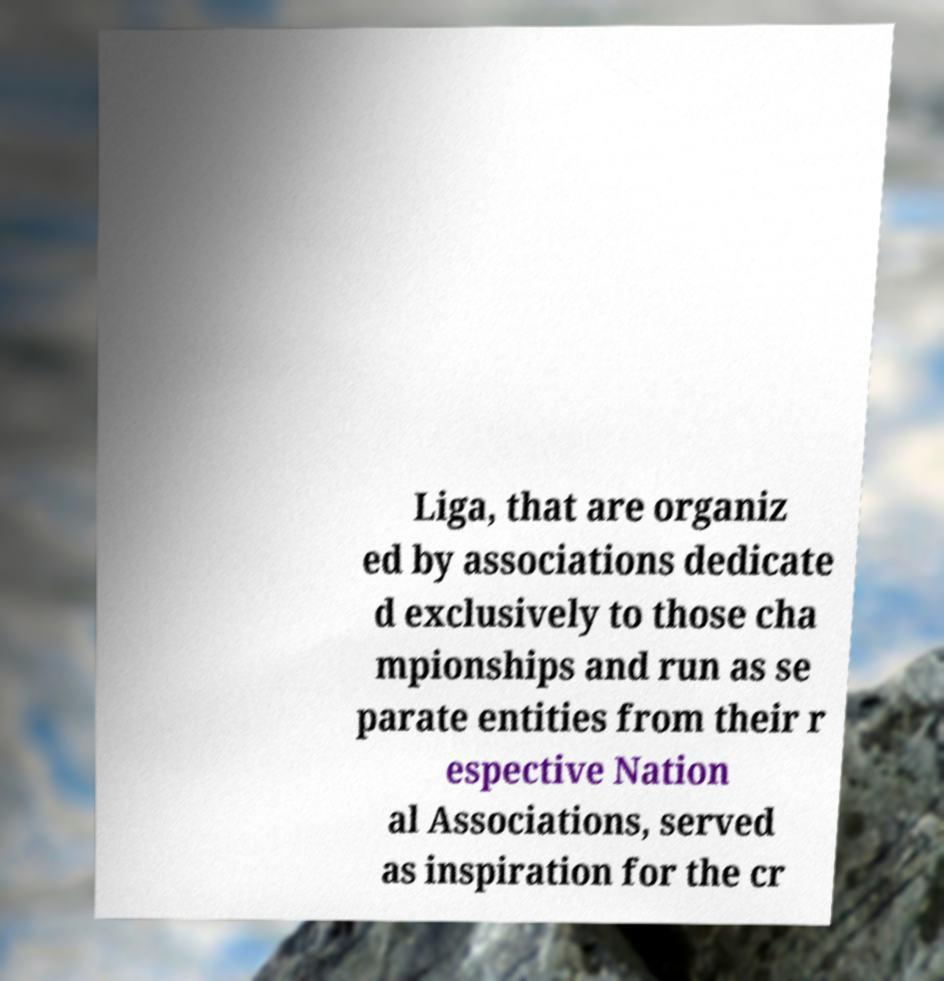I need the written content from this picture converted into text. Can you do that? Liga, that are organiz ed by associations dedicate d exclusively to those cha mpionships and run as se parate entities from their r espective Nation al Associations, served as inspiration for the cr 